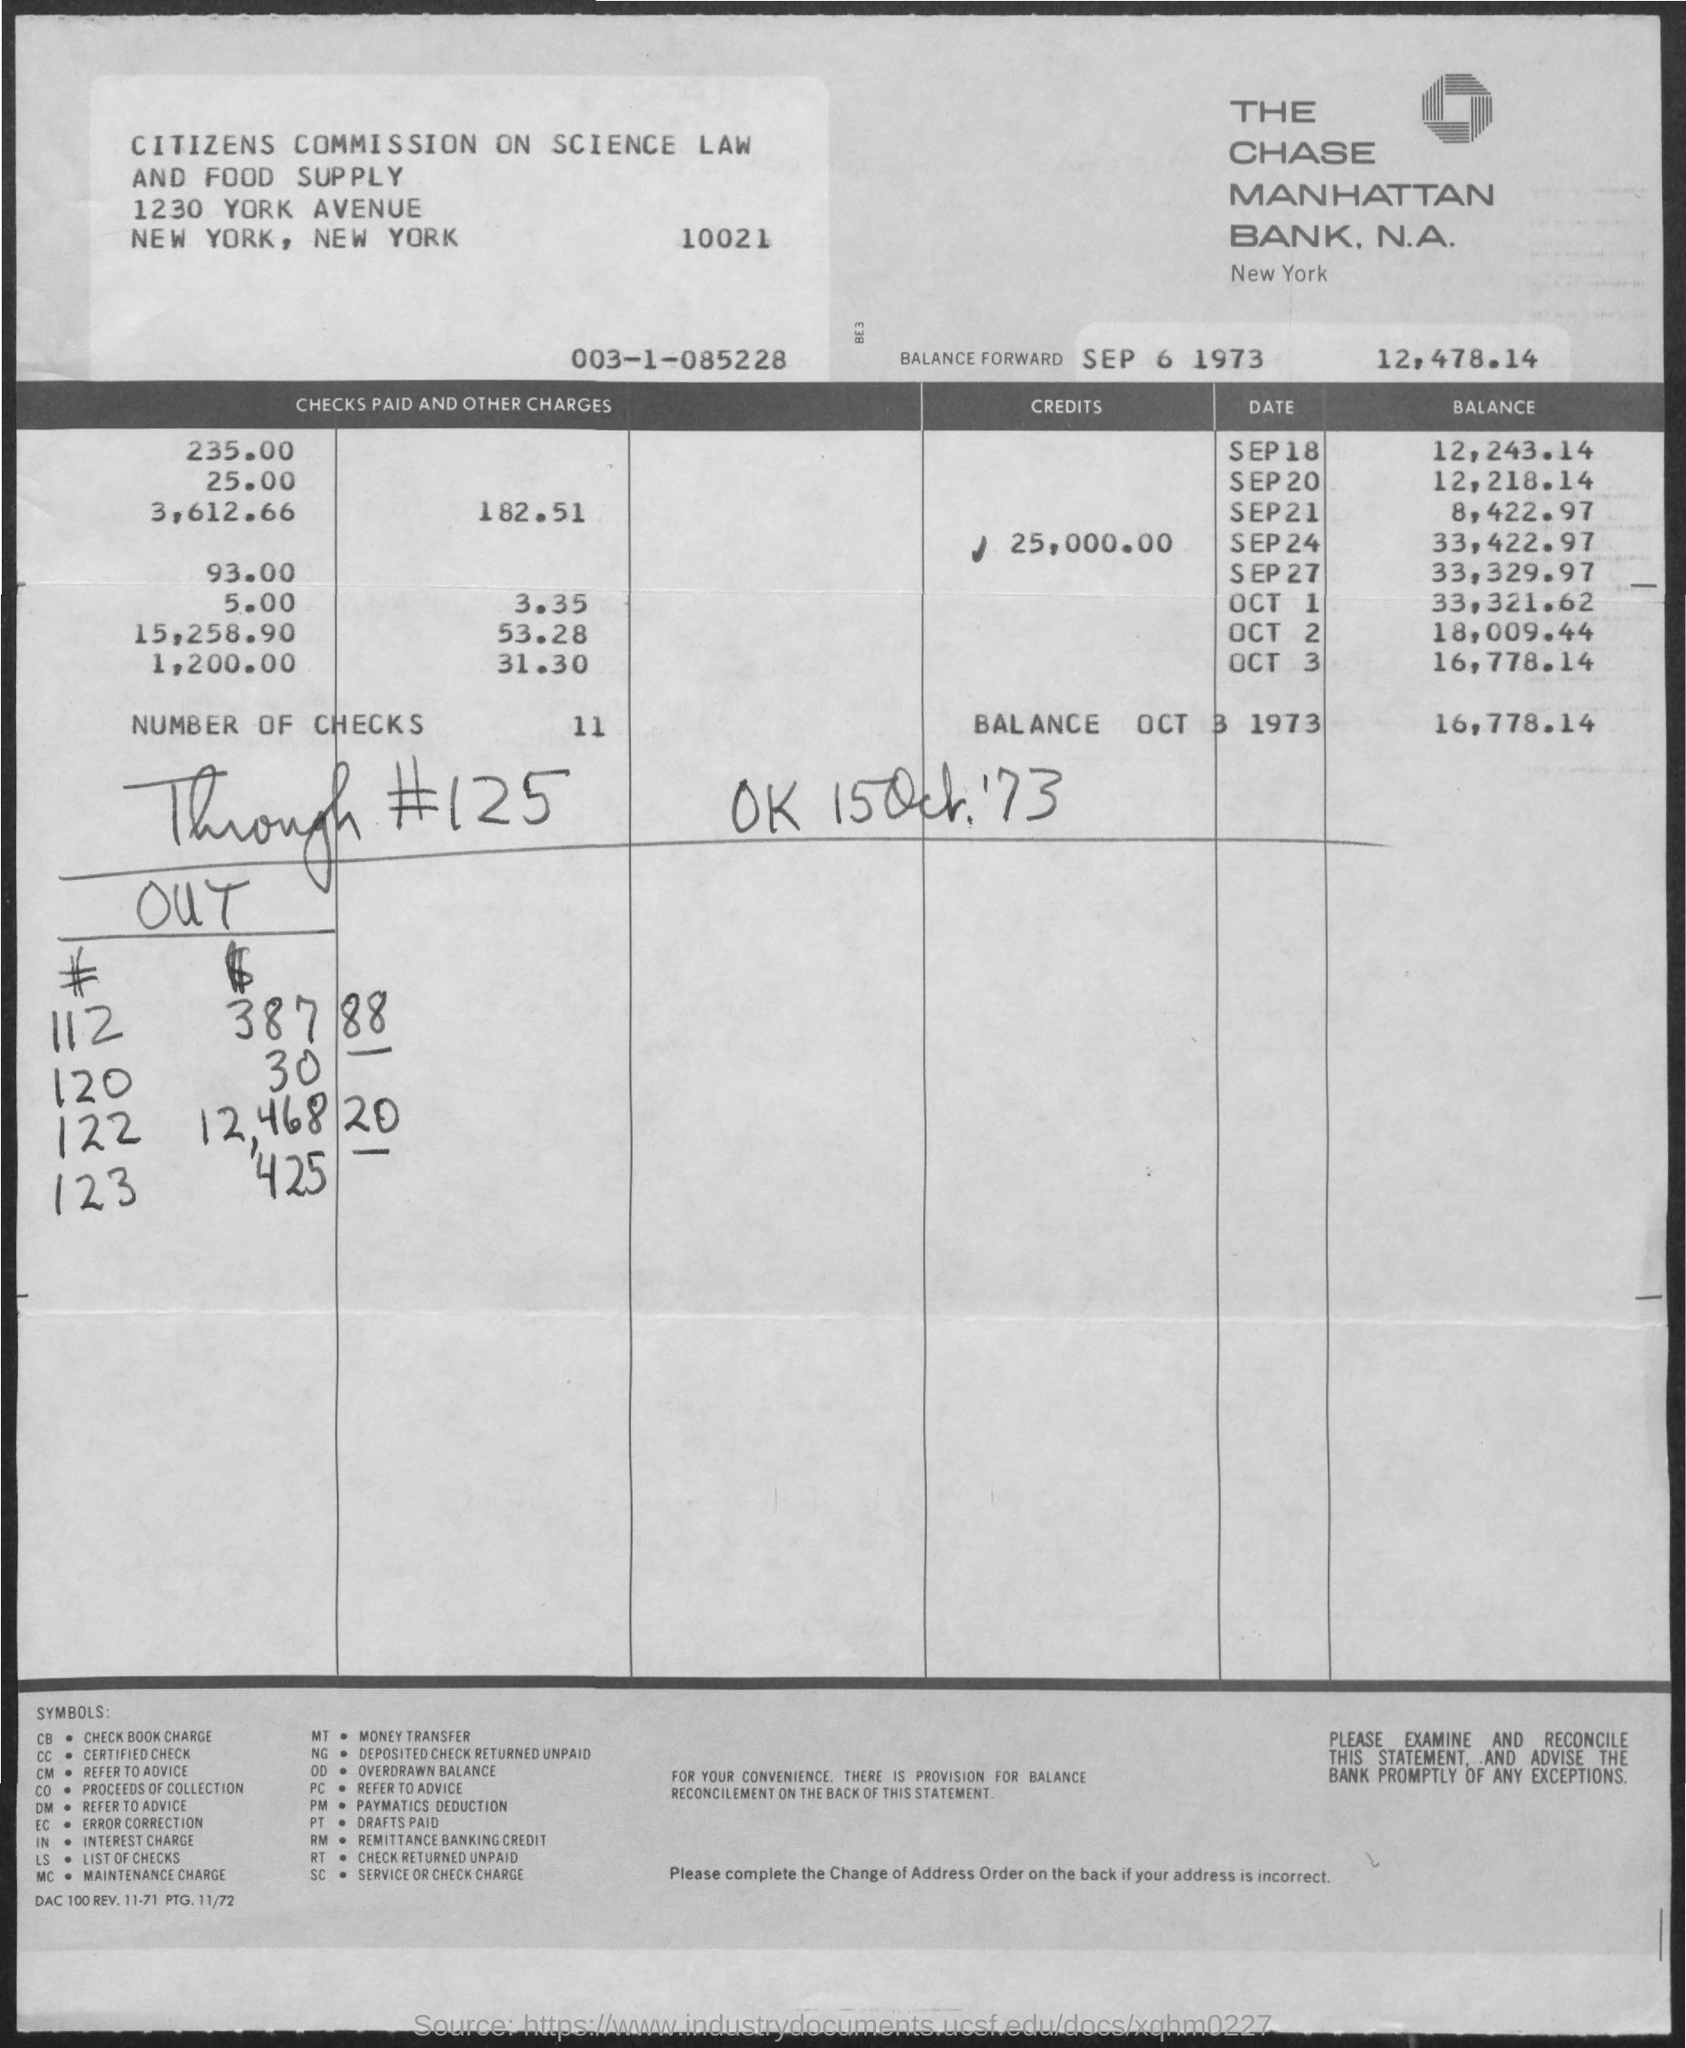Identify some key points in this picture. The Chase Manhattan bank, which is a national association, is the name of the bank. The Chase Manhattan bank is located in New York City. As of October 3, 1973, the balance was 16,778.14... The city where the Citizens' Commission on Science and Law is located is New York. There are 11 checks. 